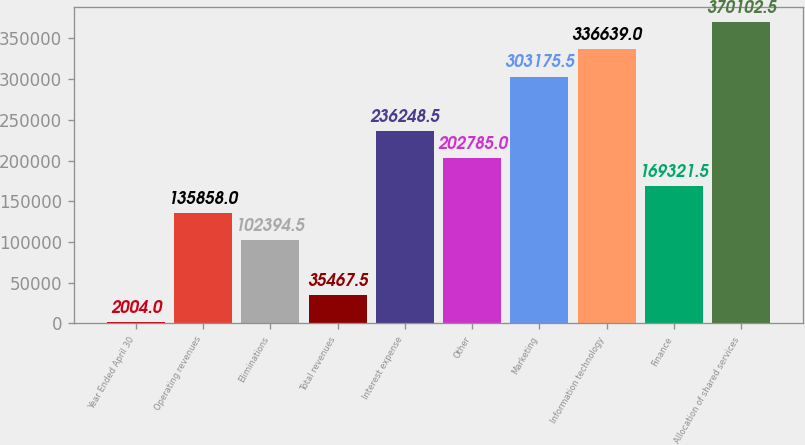<chart> <loc_0><loc_0><loc_500><loc_500><bar_chart><fcel>Year Ended April 30<fcel>Operating revenues<fcel>Eliminations<fcel>Total revenues<fcel>Interest expense<fcel>Other<fcel>Marketing<fcel>Information technology<fcel>Finance<fcel>Allocation of shared services<nl><fcel>2004<fcel>135858<fcel>102394<fcel>35467.5<fcel>236248<fcel>202785<fcel>303176<fcel>336639<fcel>169322<fcel>370102<nl></chart> 